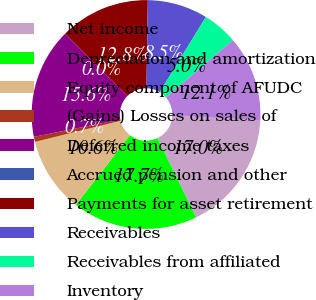<chart> <loc_0><loc_0><loc_500><loc_500><pie_chart><fcel>Net income<fcel>Depreciation and amortization<fcel>Equity component of AFUDC<fcel>(Gains) Losses on sales of<fcel>Deferred income taxes<fcel>Accrued pension and other<fcel>Payments for asset retirement<fcel>Receivables<fcel>Receivables from affiliated<fcel>Inventory<nl><fcel>17.01%<fcel>17.72%<fcel>10.64%<fcel>0.72%<fcel>15.6%<fcel>0.01%<fcel>12.76%<fcel>8.51%<fcel>4.97%<fcel>12.05%<nl></chart> 